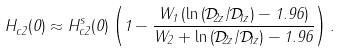Convert formula to latex. <formula><loc_0><loc_0><loc_500><loc_500>H _ { c 2 } ^ { \| } ( 0 ) \approx H _ { c 2 } ^ { s \| } ( 0 ) \left ( 1 - \frac { W _ { 1 } \left ( \ln \left ( \mathcal { D } _ { 2 z } / \mathcal { D } _ { 1 z } \right ) - 1 . 9 6 \right ) } { W _ { 2 } + \ln \left ( \mathcal { D } _ { 2 z } / \mathcal { D } _ { 1 z } \right ) - 1 . 9 6 } \right ) .</formula> 